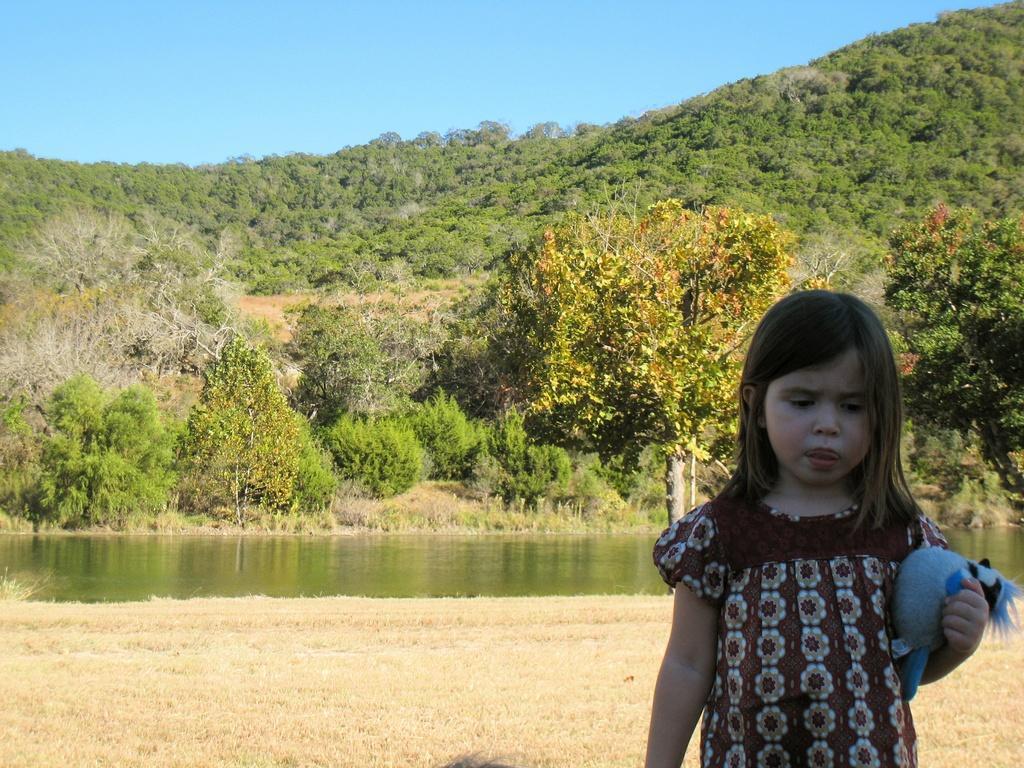Please provide a concise description of this image. In the picture we can see a girl standing on the grass surface and she is holding a doll which is blue in color and in the background, we can see water, plants, trees, hills and a sky. 